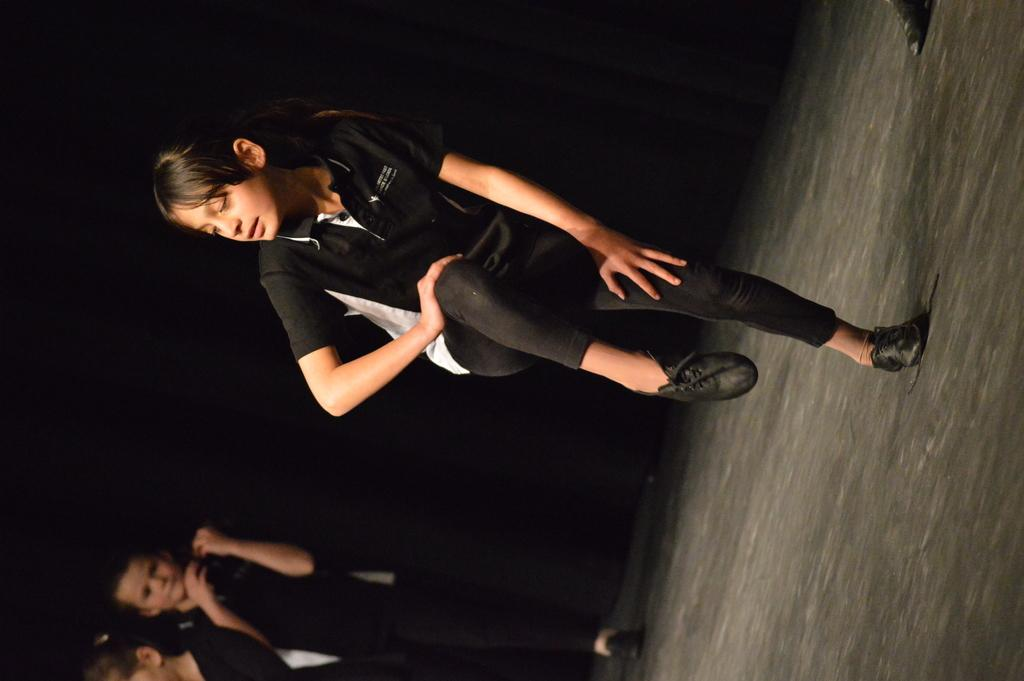Who or what is present in the image? There are people in the image. What is beneath the people in the image? There is a floor in the image. What can be observed about the background of the image? The background of the image is dark. How does the rice turn in the image? There is no rice present in the image, so it cannot turn. 